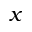Convert formula to latex. <formula><loc_0><loc_0><loc_500><loc_500>x</formula> 